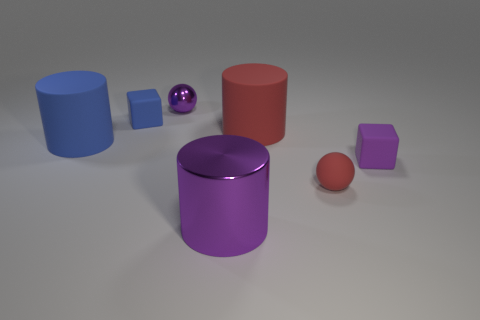Add 1 big blue objects. How many objects exist? 8 Subtract all cubes. How many objects are left? 5 Add 5 small blue matte cubes. How many small blue matte cubes exist? 6 Subtract 0 gray spheres. How many objects are left? 7 Subtract all red balls. Subtract all purple rubber things. How many objects are left? 5 Add 6 small spheres. How many small spheres are left? 8 